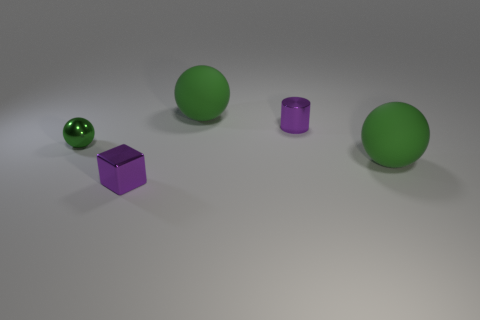Are there any tiny objects behind the rubber object in front of the purple shiny cylinder?
Your answer should be compact. Yes. Is the number of tiny shiny blocks that are in front of the metal ball less than the number of tiny shiny cylinders that are to the left of the small metallic cylinder?
Ensure brevity in your answer.  No. What is the size of the rubber sphere that is in front of the big ball that is behind the green thing on the left side of the small cube?
Offer a very short reply. Large. Does the rubber thing left of the purple metal cylinder have the same size as the small purple shiny cube?
Your answer should be compact. No. What number of other things are the same material as the cylinder?
Your answer should be compact. 2. Are there more small metallic cubes than big red metal things?
Give a very brief answer. Yes. The big thing that is right of the green rubber object to the left of the small metallic cylinder behind the tiny green thing is made of what material?
Give a very brief answer. Rubber. Is the metal cube the same color as the small cylinder?
Your answer should be compact. Yes. Is there another matte sphere that has the same color as the small ball?
Provide a succinct answer. Yes. What is the shape of the green metal object that is the same size as the purple cylinder?
Keep it short and to the point. Sphere. 